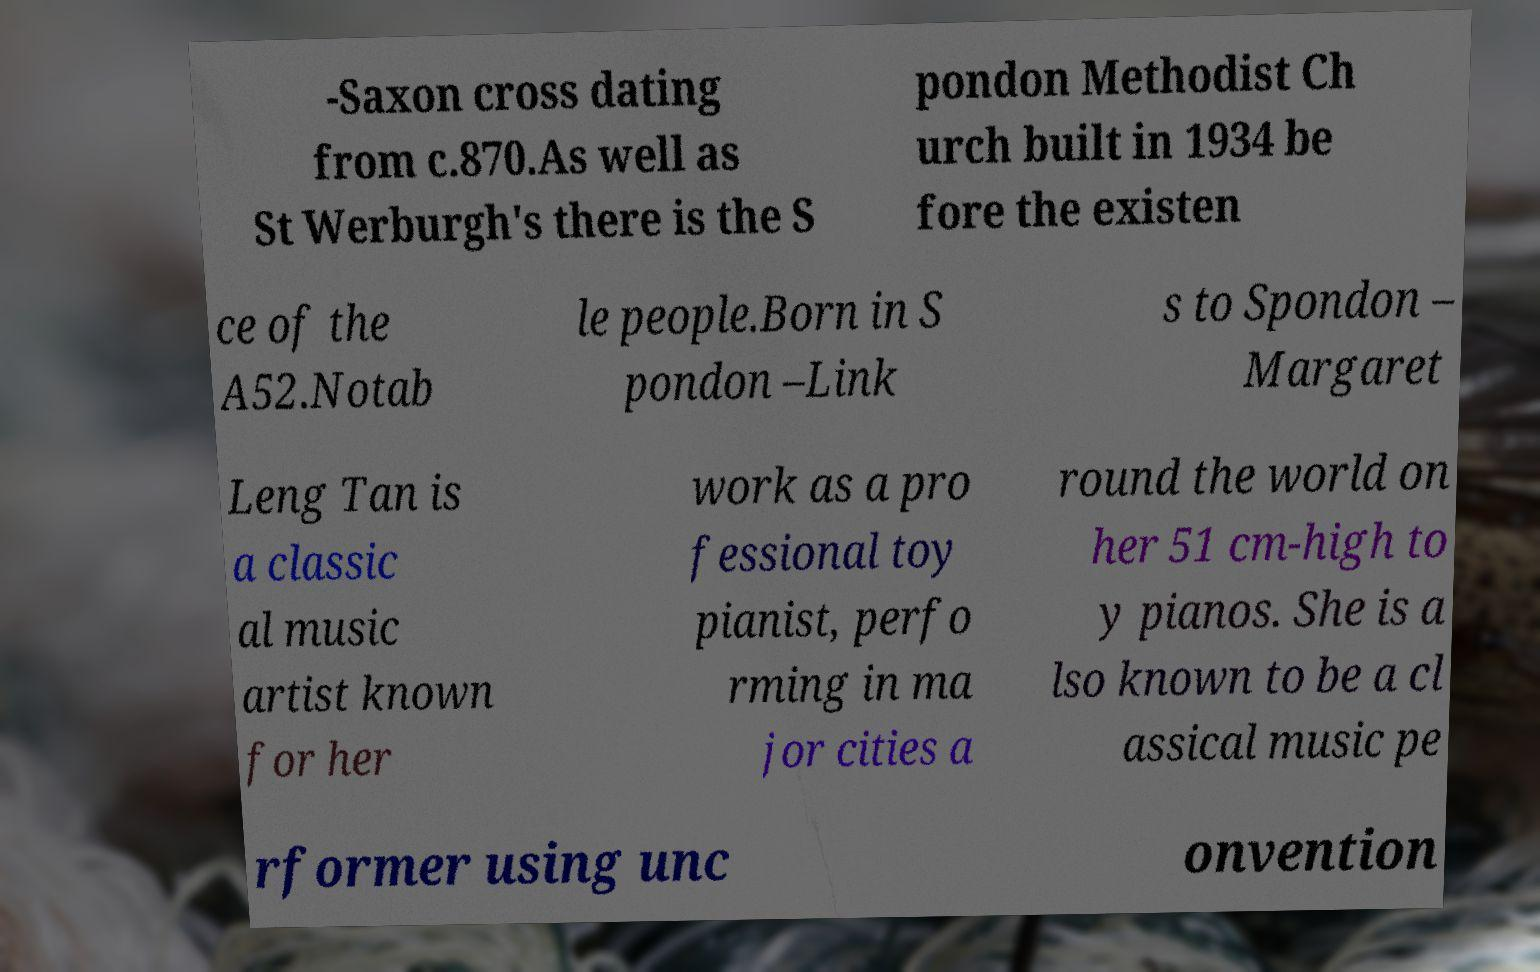Please read and relay the text visible in this image. What does it say? -Saxon cross dating from c.870.As well as St Werburgh's there is the S pondon Methodist Ch urch built in 1934 be fore the existen ce of the A52.Notab le people.Born in S pondon –Link s to Spondon – Margaret Leng Tan is a classic al music artist known for her work as a pro fessional toy pianist, perfo rming in ma jor cities a round the world on her 51 cm-high to y pianos. She is a lso known to be a cl assical music pe rformer using unc onvention 